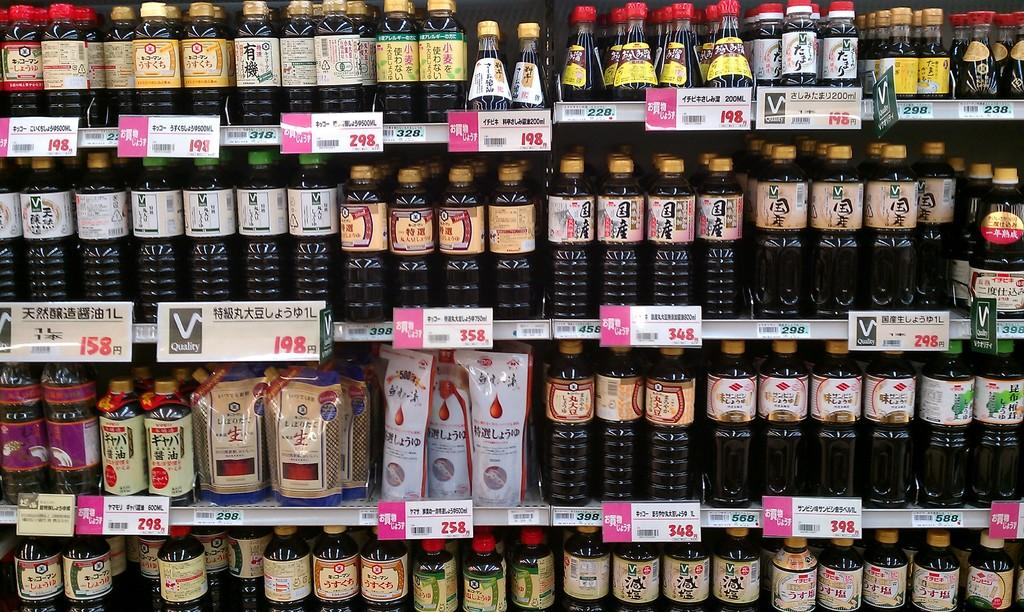<image>
Provide a brief description of the given image. The bottom right price tag has the number 398 written in red on it 